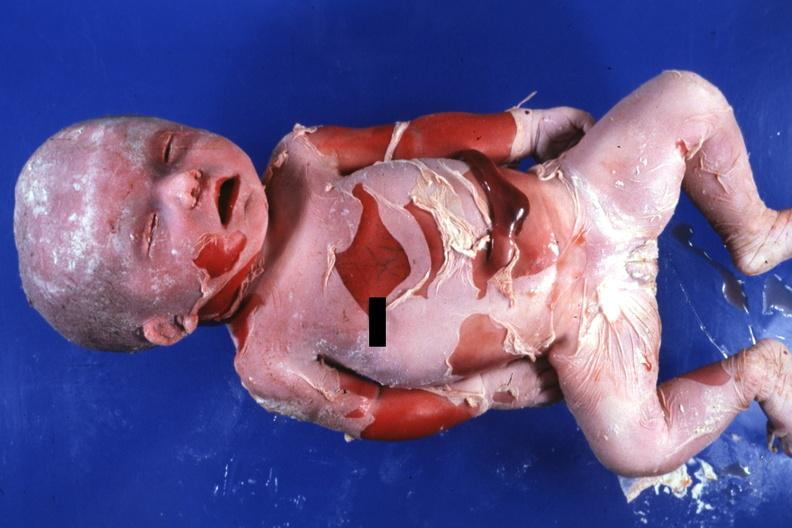what is present?
Answer the question using a single word or phrase. Macerated stillborn 